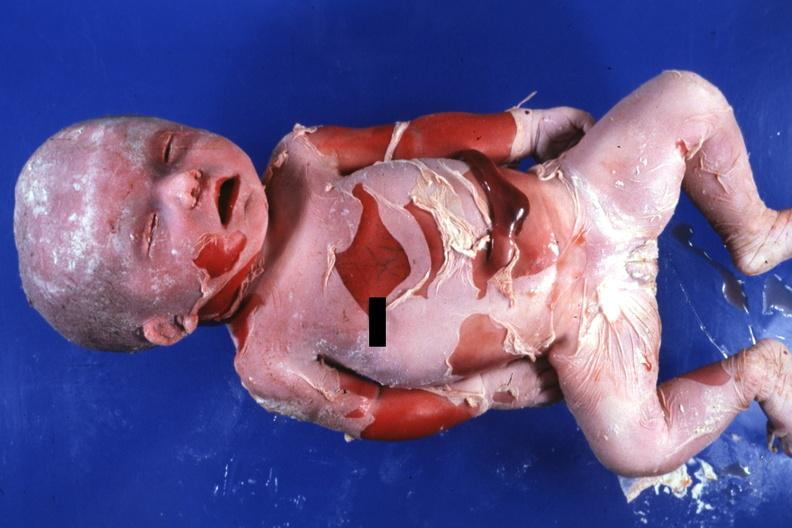what is present?
Answer the question using a single word or phrase. Macerated stillborn 